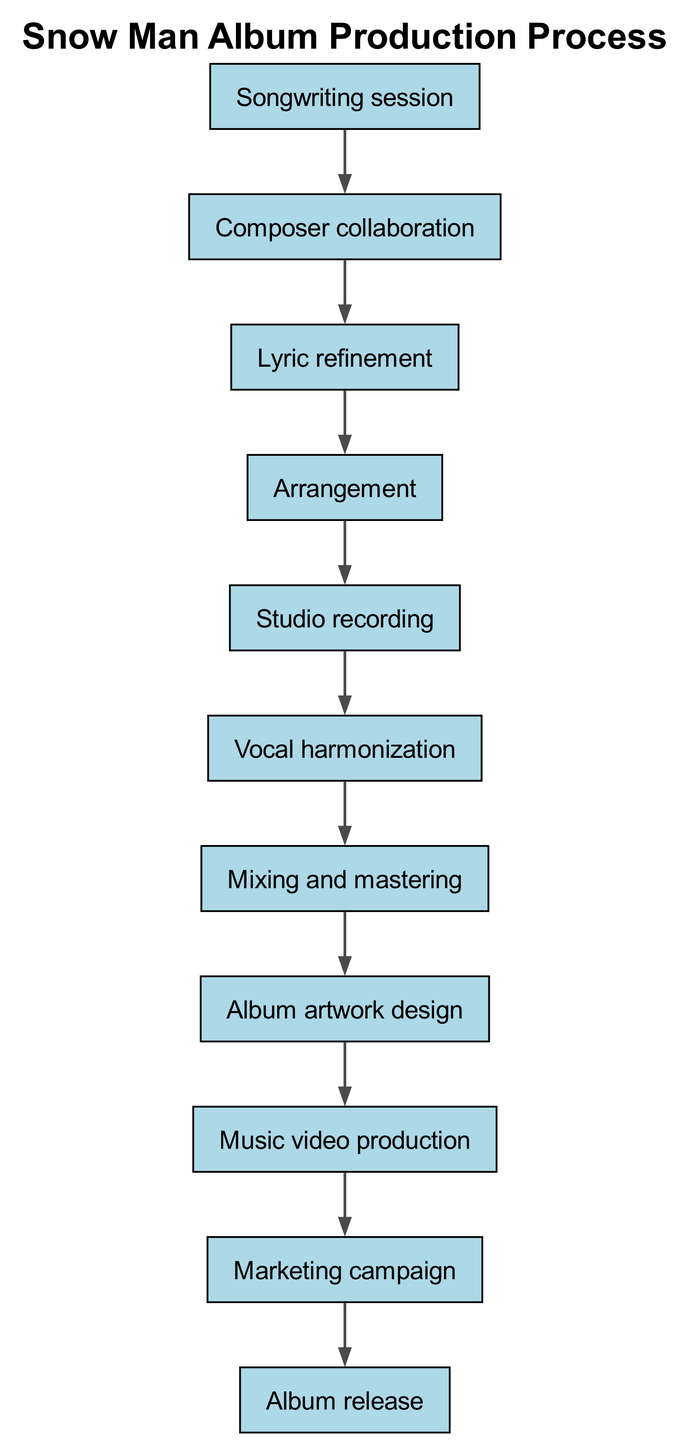What is the first step in the album production process? The first step is the "Songwriting session." It is the initial stage where ideas for songs are generated.
Answer: Songwriting session How many nodes are present in the diagram? The diagram contains a total of 11 nodes representing different stages in the album production process.
Answer: 11 What follows after "Lyric refinement"? After "Lyric refinement," the next step is "Arrangement." This indicates the flow of production from refining lyrics to arranging the music.
Answer: Arrangement Which node comes before "Vocal harmonization"? The node that comes before "Vocal harmonization" is "Studio recording." This shows that the studio recording must be completed before vocal harmonization begins.
Answer: Studio recording What is the final step in the production process? The final step in the production process is "Album release," indicating the culmination of all preceding efforts and production stages.
Answer: Album release How many steps are there between "Composer collaboration" and "Mixing and mastering"? There are four steps between "Composer collaboration" and "Mixing and mastering" which include: Lyric refinement, Arrangement, Studio recording, and Vocal harmonization.
Answer: 4 Which node has the relationship with both "Music video production" and "Album artwork design"? The node "Album artwork design" has the relationship with both "Music video production" and "Mixing and mastering," indicating it is a precursor to music video production but follows mixing and mastering.
Answer: Album artwork design What two processes are interconnected by the edge leading from "Mixing and mastering"? The edge leads from "Mixing and mastering" to "Album artwork design," indicating a direct flow from the final audio processing to the design of visual elements associated with the album.
Answer: Album artwork design If the arrangement process is delayed, which process will also be delayed? If the arrangement process is delayed, "Studio recording" will also be delayed, as these processes are sequential, and studio recording can only occur after arrangement is completed.
Answer: Studio recording 